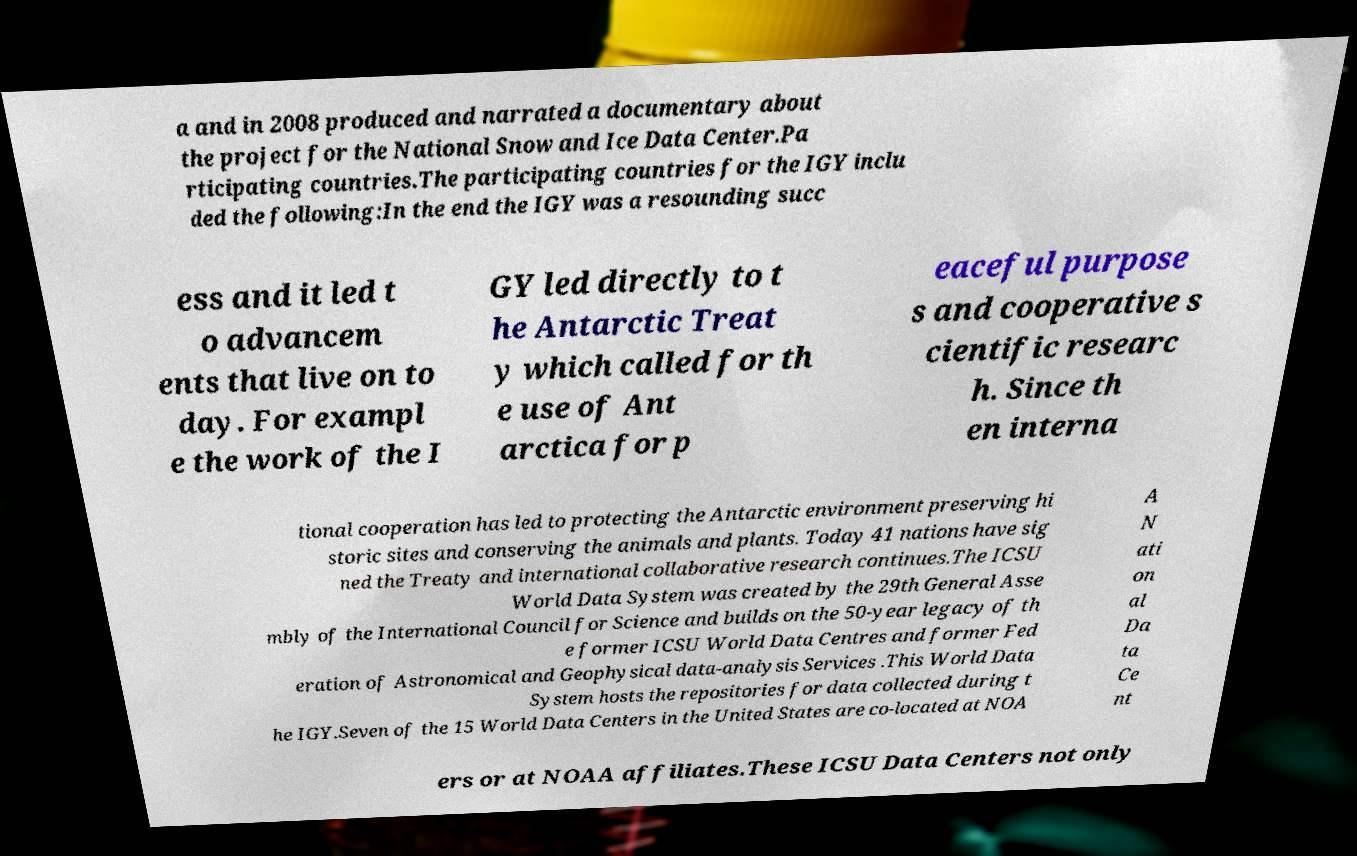I need the written content from this picture converted into text. Can you do that? a and in 2008 produced and narrated a documentary about the project for the National Snow and Ice Data Center.Pa rticipating countries.The participating countries for the IGY inclu ded the following:In the end the IGY was a resounding succ ess and it led t o advancem ents that live on to day. For exampl e the work of the I GY led directly to t he Antarctic Treat y which called for th e use of Ant arctica for p eaceful purpose s and cooperative s cientific researc h. Since th en interna tional cooperation has led to protecting the Antarctic environment preserving hi storic sites and conserving the animals and plants. Today 41 nations have sig ned the Treaty and international collaborative research continues.The ICSU World Data System was created by the 29th General Asse mbly of the International Council for Science and builds on the 50-year legacy of th e former ICSU World Data Centres and former Fed eration of Astronomical and Geophysical data-analysis Services .This World Data System hosts the repositories for data collected during t he IGY.Seven of the 15 World Data Centers in the United States are co-located at NOA A N ati on al Da ta Ce nt ers or at NOAA affiliates.These ICSU Data Centers not only 